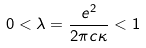Convert formula to latex. <formula><loc_0><loc_0><loc_500><loc_500>0 < \lambda = { \frac { e ^ { 2 } } { 2 \pi c \kappa } } < 1</formula> 